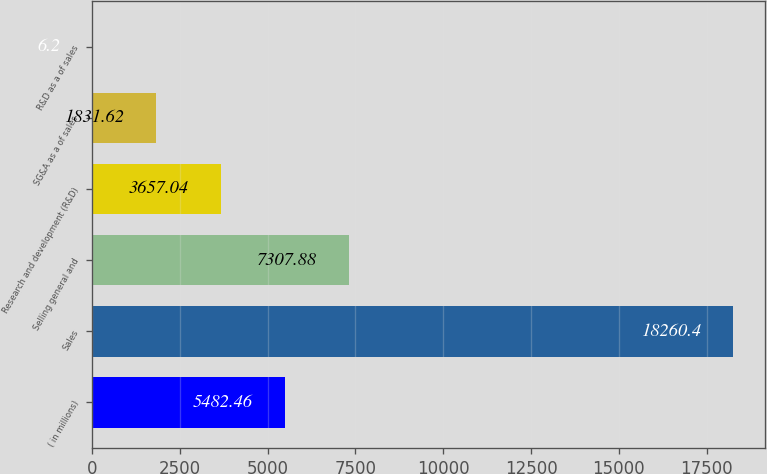Convert chart to OTSL. <chart><loc_0><loc_0><loc_500><loc_500><bar_chart><fcel>( in millions)<fcel>Sales<fcel>Selling general and<fcel>Research and development (R&D)<fcel>SG&A as a of sales<fcel>R&D as a of sales<nl><fcel>5482.46<fcel>18260.4<fcel>7307.88<fcel>3657.04<fcel>1831.62<fcel>6.2<nl></chart> 